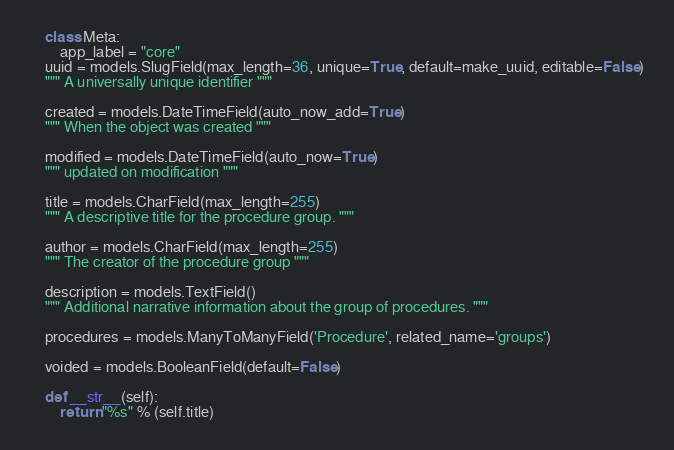Convert code to text. <code><loc_0><loc_0><loc_500><loc_500><_Python_>
    class Meta:
        app_label = "core"
    uuid = models.SlugField(max_length=36, unique=True, default=make_uuid, editable=False)
    """ A universally unique identifier """
    
    created = models.DateTimeField(auto_now_add=True)
    """ When the object was created """
    
    modified = models.DateTimeField(auto_now=True)
    """ updated on modification """
   
    title = models.CharField(max_length=255)
    """ A descriptive title for the procedure group. """
   
    author = models.CharField(max_length=255)
    """ The creator of the procedure group """
    
    description = models.TextField()
    """ Additional narrative information about the group of procedures. """
    
    procedures = models.ManyToManyField('Procedure', related_name='groups')

    voided = models.BooleanField(default=False)

    def __str__(self):
        return "%s" % (self.title)

</code> 